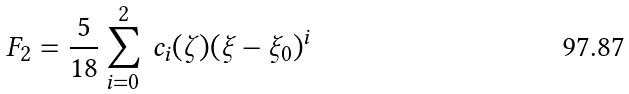<formula> <loc_0><loc_0><loc_500><loc_500>F _ { 2 } = \frac { 5 } { 1 8 } \sum _ { i = 0 } ^ { 2 } \, c _ { i } ( \zeta ) ( \xi - \xi _ { 0 } ) ^ { i }</formula> 